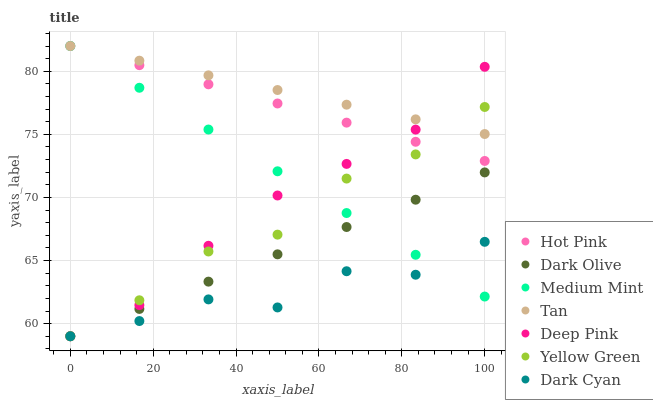Does Dark Cyan have the minimum area under the curve?
Answer yes or no. Yes. Does Tan have the maximum area under the curve?
Answer yes or no. Yes. Does Hot Pink have the minimum area under the curve?
Answer yes or no. No. Does Hot Pink have the maximum area under the curve?
Answer yes or no. No. Is Tan the smoothest?
Answer yes or no. Yes. Is Dark Cyan the roughest?
Answer yes or no. Yes. Is Hot Pink the smoothest?
Answer yes or no. No. Is Hot Pink the roughest?
Answer yes or no. No. Does Yellow Green have the lowest value?
Answer yes or no. Yes. Does Hot Pink have the lowest value?
Answer yes or no. No. Does Tan have the highest value?
Answer yes or no. Yes. Does Yellow Green have the highest value?
Answer yes or no. No. Is Dark Cyan less than Hot Pink?
Answer yes or no. Yes. Is Hot Pink greater than Dark Cyan?
Answer yes or no. Yes. Does Medium Mint intersect Dark Olive?
Answer yes or no. Yes. Is Medium Mint less than Dark Olive?
Answer yes or no. No. Is Medium Mint greater than Dark Olive?
Answer yes or no. No. Does Dark Cyan intersect Hot Pink?
Answer yes or no. No. 